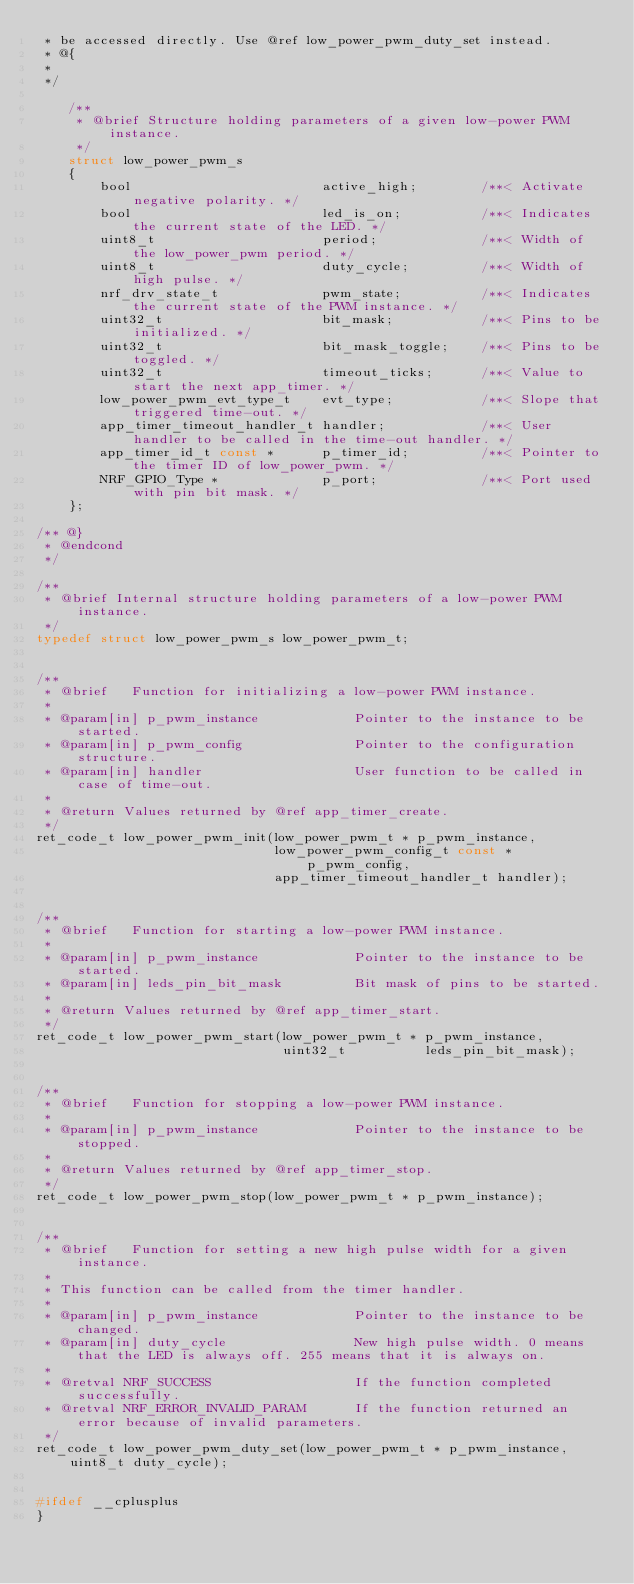Convert code to text. <code><loc_0><loc_0><loc_500><loc_500><_C_> * be accessed directly. Use @ref low_power_pwm_duty_set instead.
 * @{
 *
 */

    /**
     * @brief Structure holding parameters of a given low-power PWM instance.
     */
    struct low_power_pwm_s
    {
        bool                        active_high;        /**< Activate negative polarity. */
        bool                        led_is_on;          /**< Indicates the current state of the LED. */
        uint8_t                     period;             /**< Width of the low_power_pwm period. */
        uint8_t                     duty_cycle;         /**< Width of high pulse. */
        nrf_drv_state_t             pwm_state;          /**< Indicates the current state of the PWM instance. */
        uint32_t                    bit_mask;           /**< Pins to be initialized. */
        uint32_t                    bit_mask_toggle;    /**< Pins to be toggled. */
        uint32_t                    timeout_ticks;      /**< Value to start the next app_timer. */
        low_power_pwm_evt_type_t    evt_type;           /**< Slope that triggered time-out. */
        app_timer_timeout_handler_t handler;            /**< User handler to be called in the time-out handler. */
        app_timer_id_t const *      p_timer_id;         /**< Pointer to the timer ID of low_power_pwm. */
        NRF_GPIO_Type *             p_port;             /**< Port used with pin bit mask. */
    };

/** @}
 * @endcond
 */

/**
 * @brief Internal structure holding parameters of a low-power PWM instance.
 */
typedef struct low_power_pwm_s low_power_pwm_t;


/**
 * @brief   Function for initializing a low-power PWM instance.
 *
 * @param[in] p_pwm_instance            Pointer to the instance to be started.
 * @param[in] p_pwm_config              Pointer to the configuration structure.
 * @param[in] handler                   User function to be called in case of time-out.
 *
 * @return Values returned by @ref app_timer_create.
 */
ret_code_t low_power_pwm_init(low_power_pwm_t * p_pwm_instance,
                              low_power_pwm_config_t const * p_pwm_config,
                              app_timer_timeout_handler_t handler);


/**
 * @brief   Function for starting a low-power PWM instance.
 *
 * @param[in] p_pwm_instance            Pointer to the instance to be started.
 * @param[in] leds_pin_bit_mask         Bit mask of pins to be started.
 *
 * @return Values returned by @ref app_timer_start.
 */
ret_code_t low_power_pwm_start(low_power_pwm_t * p_pwm_instance,
                               uint32_t          leds_pin_bit_mask);


/**
 * @brief   Function for stopping a low-power PWM instance.
 *
 * @param[in] p_pwm_instance            Pointer to the instance to be stopped.
 *
 * @return Values returned by @ref app_timer_stop.
 */
ret_code_t low_power_pwm_stop(low_power_pwm_t * p_pwm_instance);


/**
 * @brief   Function for setting a new high pulse width for a given instance.
 *
 * This function can be called from the timer handler.
 *
 * @param[in] p_pwm_instance            Pointer to the instance to be changed.
 * @param[in] duty_cycle                New high pulse width. 0 means that the LED is always off. 255 means that it is always on.
 *
 * @retval NRF_SUCCESS                  If the function completed successfully.
 * @retval NRF_ERROR_INVALID_PARAM      If the function returned an error because of invalid parameters.
 */
ret_code_t low_power_pwm_duty_set(low_power_pwm_t * p_pwm_instance, uint8_t duty_cycle);


#ifdef __cplusplus
}</code> 